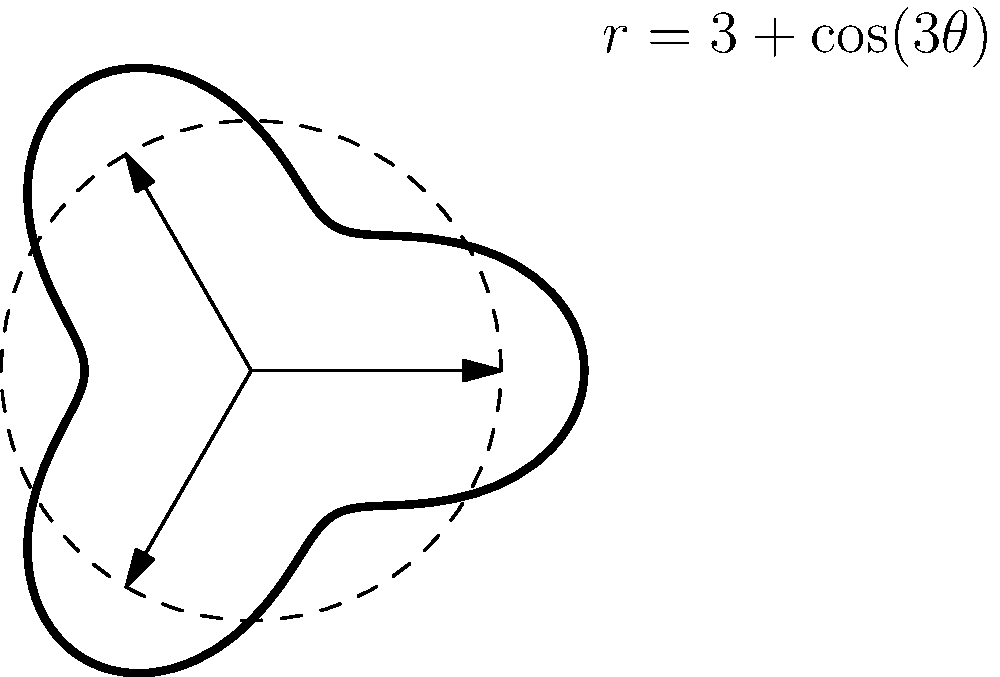You are designing a circular throwing knife with aerodynamic cutouts. The knife's edge is represented in polar coordinates by the equation $r = 3 + \cos(3\theta)$, where $r$ is in inches. What is the total area of the cutouts in square inches? To find the area of the cutouts, we need to:

1) Calculate the area of the circular knife without cutouts:
   $$A_{circle} = \pi r^2 = \pi \cdot 3^2 = 9\pi \text{ sq in}$$

2) Calculate the area of the knife with cutouts using the polar equation:
   $$A_{knife} = \frac{1}{2} \int_{0}^{2\pi} r^2 d\theta$$
   $$A_{knife} = \frac{1}{2} \int_{0}^{2\pi} (3 + \cos(3\theta))^2 d\theta$$
   $$A_{knife} = \frac{1}{2} \int_{0}^{2\pi} (9 + 6\cos(3\theta) + \cos^2(3\theta)) d\theta$$

3) Integrate:
   $$A_{knife} = \frac{1}{2} [9\theta + 2\sin(3\theta) + \frac{1}{2}\theta + \frac{1}{6}\sin(6\theta)]_{0}^{2\pi}$$
   $$A_{knife} = \frac{1}{2} [18\pi + \pi] = \frac{19\pi}{2} \text{ sq in}$$

4) Calculate the difference:
   $$A_{cutouts} = A_{circle} - A_{knife} = 9\pi - \frac{19\pi}{2} = \frac{-\pi}{2} \text{ sq in}$$

5) Take the absolute value for the area:
   $$A_{cutouts} = |\frac{-\pi}{2}| = \frac{\pi}{2} \text{ sq in}$$
Answer: $\frac{\pi}{2}$ square inches 